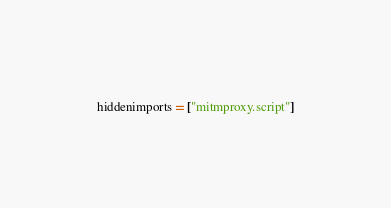Convert code to text. <code><loc_0><loc_0><loc_500><loc_500><_Python_>hiddenimports = ["mitmproxy.script"]
</code> 